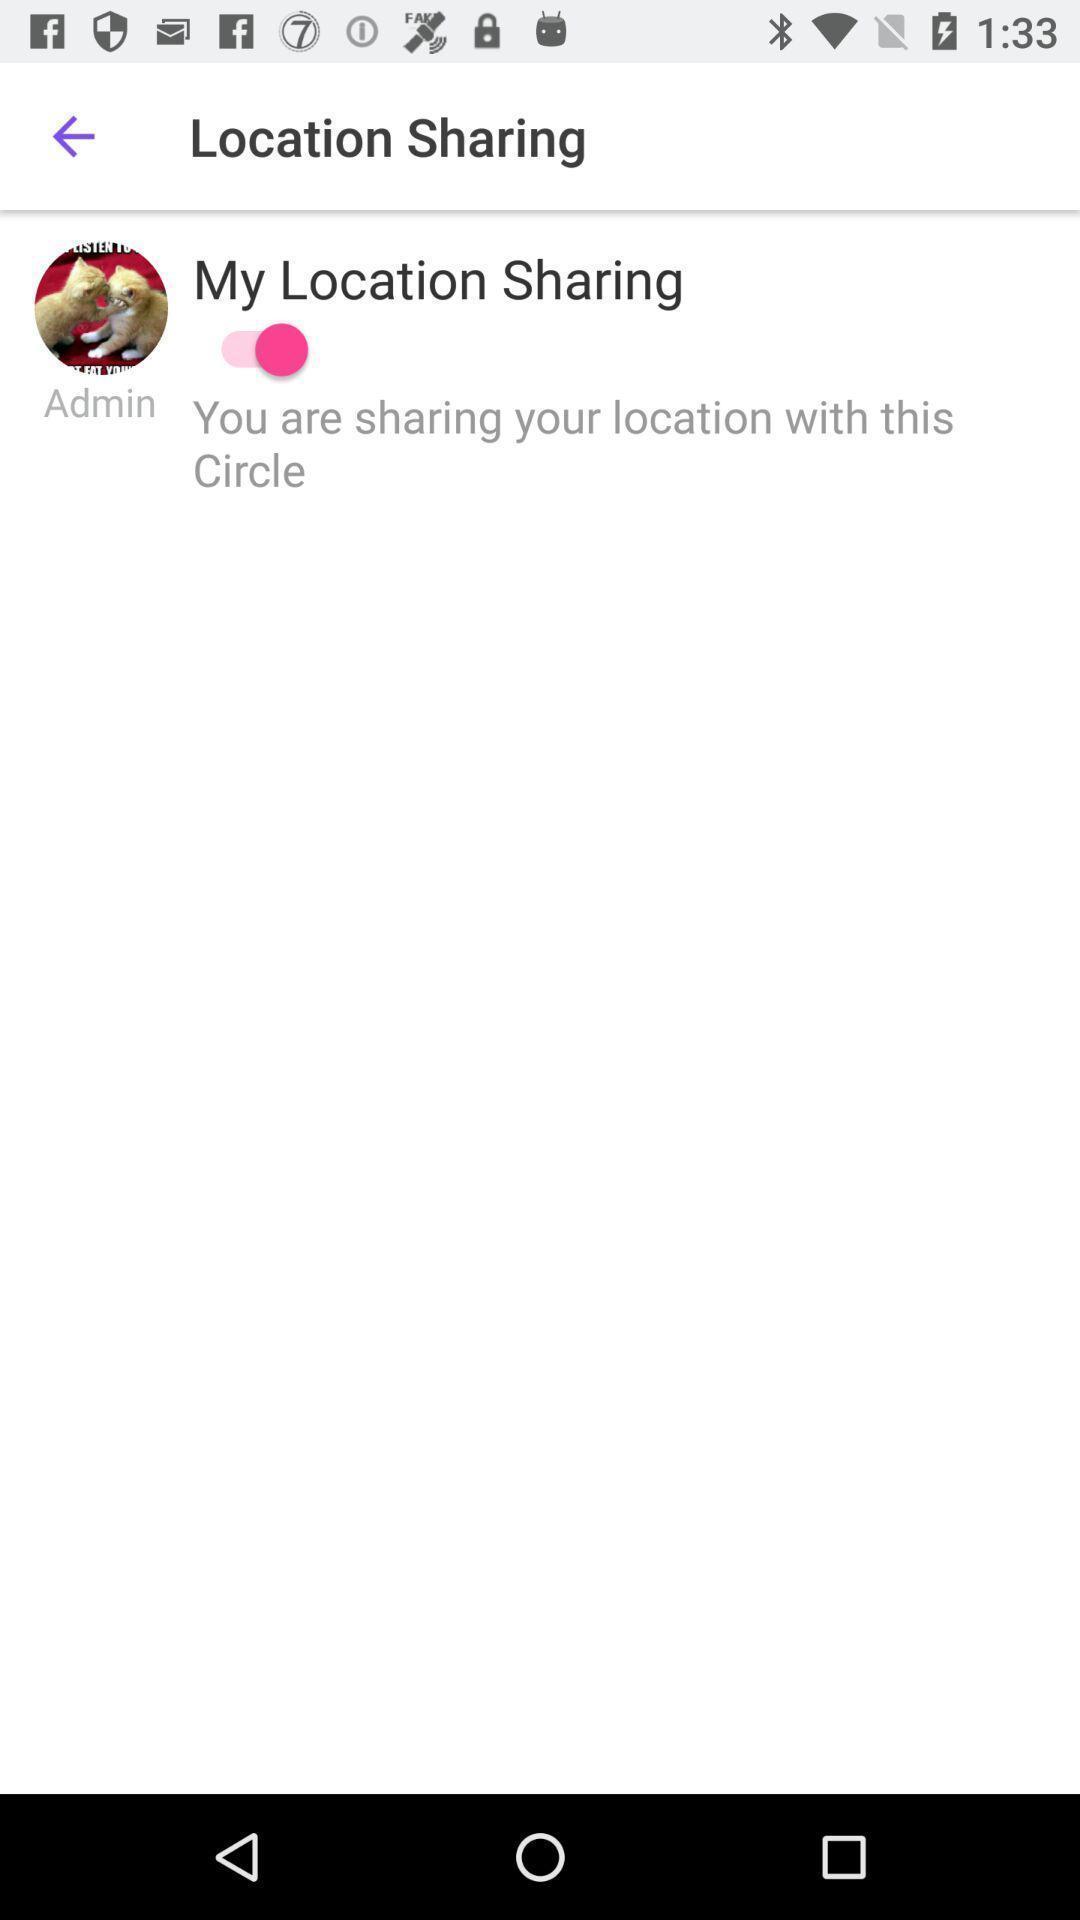What can you discern from this picture? Page to share location in application. 